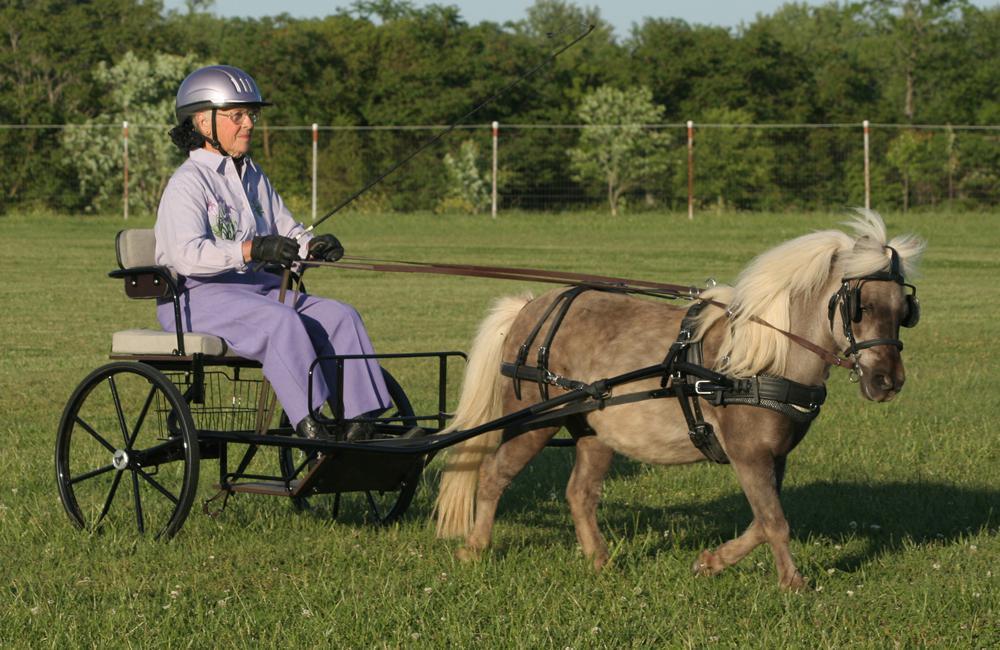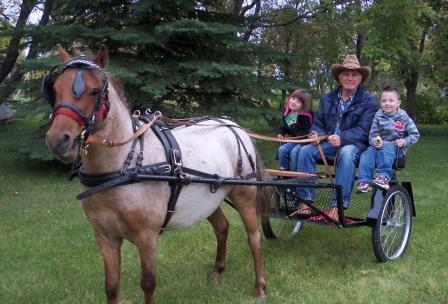The first image is the image on the left, the second image is the image on the right. Analyze the images presented: Is the assertion "There are two humans riding a horse carriage in one of the images." valid? Answer yes or no. No. The first image is the image on the left, the second image is the image on the right. For the images displayed, is the sentence "There is one human being pulled by a horse facing right." factually correct? Answer yes or no. Yes. 